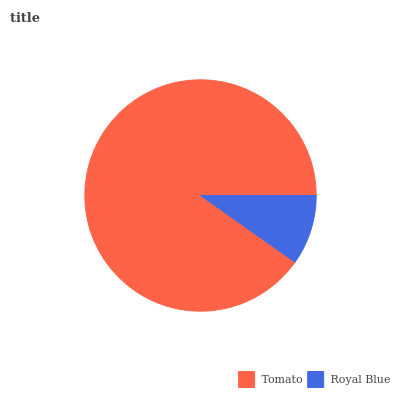Is Royal Blue the minimum?
Answer yes or no. Yes. Is Tomato the maximum?
Answer yes or no. Yes. Is Royal Blue the maximum?
Answer yes or no. No. Is Tomato greater than Royal Blue?
Answer yes or no. Yes. Is Royal Blue less than Tomato?
Answer yes or no. Yes. Is Royal Blue greater than Tomato?
Answer yes or no. No. Is Tomato less than Royal Blue?
Answer yes or no. No. Is Tomato the high median?
Answer yes or no. Yes. Is Royal Blue the low median?
Answer yes or no. Yes. Is Royal Blue the high median?
Answer yes or no. No. Is Tomato the low median?
Answer yes or no. No. 